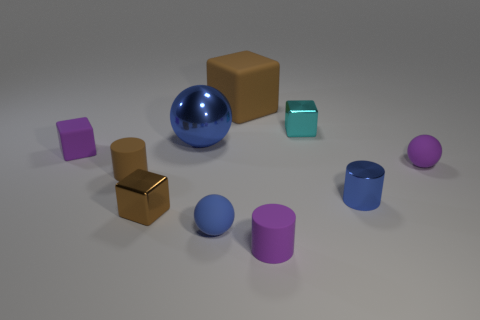Are there any patterns in the arrangement of these objects? The objects do not appear to follow a specific pattern in terms of arrangement; however, they are spatially distributed in a way that gives the scene a balanced composition. 